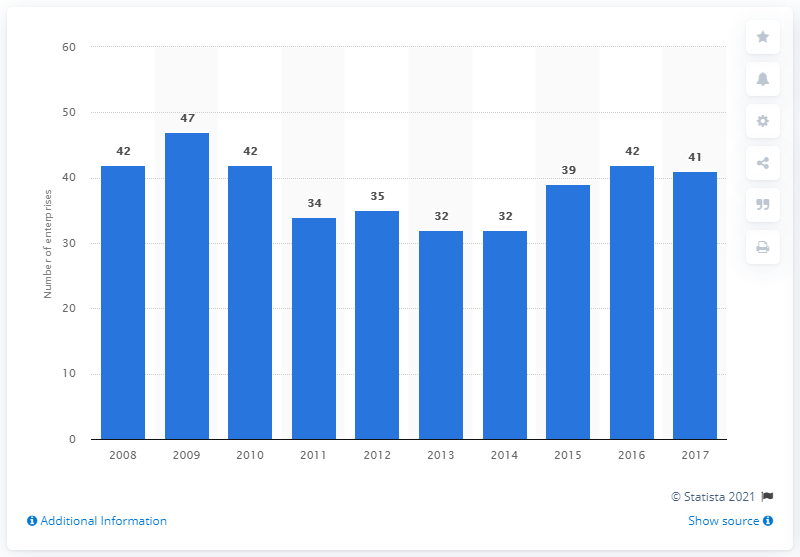Indicate a few pertinent items in this graphic. In 2017, there were 41 enterprises in Bulgaria that manufactured electric domestic appliances. 